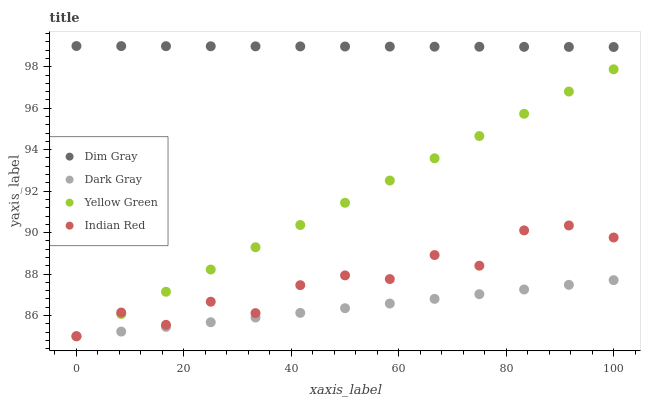Does Dark Gray have the minimum area under the curve?
Answer yes or no. Yes. Does Dim Gray have the maximum area under the curve?
Answer yes or no. Yes. Does Yellow Green have the minimum area under the curve?
Answer yes or no. No. Does Yellow Green have the maximum area under the curve?
Answer yes or no. No. Is Yellow Green the smoothest?
Answer yes or no. Yes. Is Indian Red the roughest?
Answer yes or no. Yes. Is Dim Gray the smoothest?
Answer yes or no. No. Is Dim Gray the roughest?
Answer yes or no. No. Does Dark Gray have the lowest value?
Answer yes or no. Yes. Does Dim Gray have the lowest value?
Answer yes or no. No. Does Dim Gray have the highest value?
Answer yes or no. Yes. Does Yellow Green have the highest value?
Answer yes or no. No. Is Yellow Green less than Dim Gray?
Answer yes or no. Yes. Is Dim Gray greater than Yellow Green?
Answer yes or no. Yes. Does Indian Red intersect Yellow Green?
Answer yes or no. Yes. Is Indian Red less than Yellow Green?
Answer yes or no. No. Is Indian Red greater than Yellow Green?
Answer yes or no. No. Does Yellow Green intersect Dim Gray?
Answer yes or no. No. 